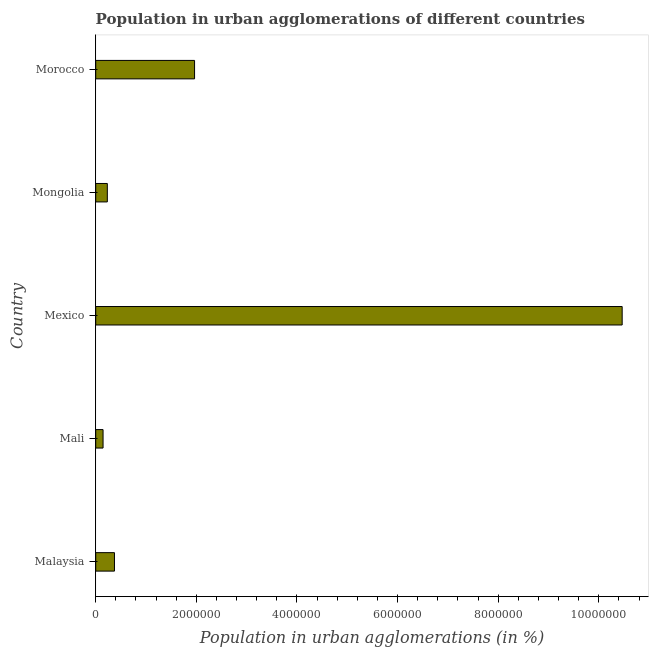Does the graph contain any zero values?
Provide a succinct answer. No. Does the graph contain grids?
Your answer should be compact. No. What is the title of the graph?
Offer a very short reply. Population in urban agglomerations of different countries. What is the label or title of the X-axis?
Offer a terse response. Population in urban agglomerations (in %). What is the label or title of the Y-axis?
Offer a terse response. Country. What is the population in urban agglomerations in Mexico?
Your answer should be very brief. 1.05e+07. Across all countries, what is the maximum population in urban agglomerations?
Your response must be concise. 1.05e+07. Across all countries, what is the minimum population in urban agglomerations?
Give a very brief answer. 1.46e+05. In which country was the population in urban agglomerations maximum?
Provide a short and direct response. Mexico. In which country was the population in urban agglomerations minimum?
Provide a short and direct response. Mali. What is the sum of the population in urban agglomerations?
Make the answer very short. 1.32e+07. What is the difference between the population in urban agglomerations in Mexico and Mongolia?
Make the answer very short. 1.02e+07. What is the average population in urban agglomerations per country?
Give a very brief answer. 2.64e+06. What is the median population in urban agglomerations?
Your answer should be compact. 3.73e+05. What is the ratio of the population in urban agglomerations in Mongolia to that in Morocco?
Your answer should be compact. 0.12. Is the difference between the population in urban agglomerations in Mali and Mexico greater than the difference between any two countries?
Ensure brevity in your answer.  Yes. What is the difference between the highest and the second highest population in urban agglomerations?
Keep it short and to the point. 8.50e+06. Is the sum of the population in urban agglomerations in Malaysia and Mali greater than the maximum population in urban agglomerations across all countries?
Give a very brief answer. No. What is the difference between the highest and the lowest population in urban agglomerations?
Give a very brief answer. 1.03e+07. In how many countries, is the population in urban agglomerations greater than the average population in urban agglomerations taken over all countries?
Give a very brief answer. 1. How many bars are there?
Your answer should be compact. 5. What is the difference between two consecutive major ticks on the X-axis?
Give a very brief answer. 2.00e+06. What is the Population in urban agglomerations (in %) in Malaysia?
Your response must be concise. 3.73e+05. What is the Population in urban agglomerations (in %) of Mali?
Your response must be concise. 1.46e+05. What is the Population in urban agglomerations (in %) of Mexico?
Offer a very short reply. 1.05e+07. What is the Population in urban agglomerations (in %) of Mongolia?
Make the answer very short. 2.31e+05. What is the Population in urban agglomerations (in %) of Morocco?
Keep it short and to the point. 1.96e+06. What is the difference between the Population in urban agglomerations (in %) in Malaysia and Mali?
Provide a short and direct response. 2.27e+05. What is the difference between the Population in urban agglomerations (in %) in Malaysia and Mexico?
Offer a very short reply. -1.01e+07. What is the difference between the Population in urban agglomerations (in %) in Malaysia and Mongolia?
Give a very brief answer. 1.42e+05. What is the difference between the Population in urban agglomerations (in %) in Malaysia and Morocco?
Ensure brevity in your answer.  -1.59e+06. What is the difference between the Population in urban agglomerations (in %) in Mali and Mexico?
Offer a very short reply. -1.03e+07. What is the difference between the Population in urban agglomerations (in %) in Mali and Mongolia?
Offer a very short reply. -8.48e+04. What is the difference between the Population in urban agglomerations (in %) in Mali and Morocco?
Provide a short and direct response. -1.82e+06. What is the difference between the Population in urban agglomerations (in %) in Mexico and Mongolia?
Provide a succinct answer. 1.02e+07. What is the difference between the Population in urban agglomerations (in %) in Mexico and Morocco?
Keep it short and to the point. 8.50e+06. What is the difference between the Population in urban agglomerations (in %) in Mongolia and Morocco?
Your response must be concise. -1.73e+06. What is the ratio of the Population in urban agglomerations (in %) in Malaysia to that in Mali?
Your answer should be compact. 2.55. What is the ratio of the Population in urban agglomerations (in %) in Malaysia to that in Mexico?
Offer a very short reply. 0.04. What is the ratio of the Population in urban agglomerations (in %) in Malaysia to that in Mongolia?
Ensure brevity in your answer.  1.61. What is the ratio of the Population in urban agglomerations (in %) in Malaysia to that in Morocco?
Your answer should be very brief. 0.19. What is the ratio of the Population in urban agglomerations (in %) in Mali to that in Mexico?
Provide a succinct answer. 0.01. What is the ratio of the Population in urban agglomerations (in %) in Mali to that in Mongolia?
Provide a succinct answer. 0.63. What is the ratio of the Population in urban agglomerations (in %) in Mali to that in Morocco?
Provide a short and direct response. 0.07. What is the ratio of the Population in urban agglomerations (in %) in Mexico to that in Mongolia?
Provide a succinct answer. 45.34. What is the ratio of the Population in urban agglomerations (in %) in Mexico to that in Morocco?
Offer a terse response. 5.33. What is the ratio of the Population in urban agglomerations (in %) in Mongolia to that in Morocco?
Keep it short and to the point. 0.12. 